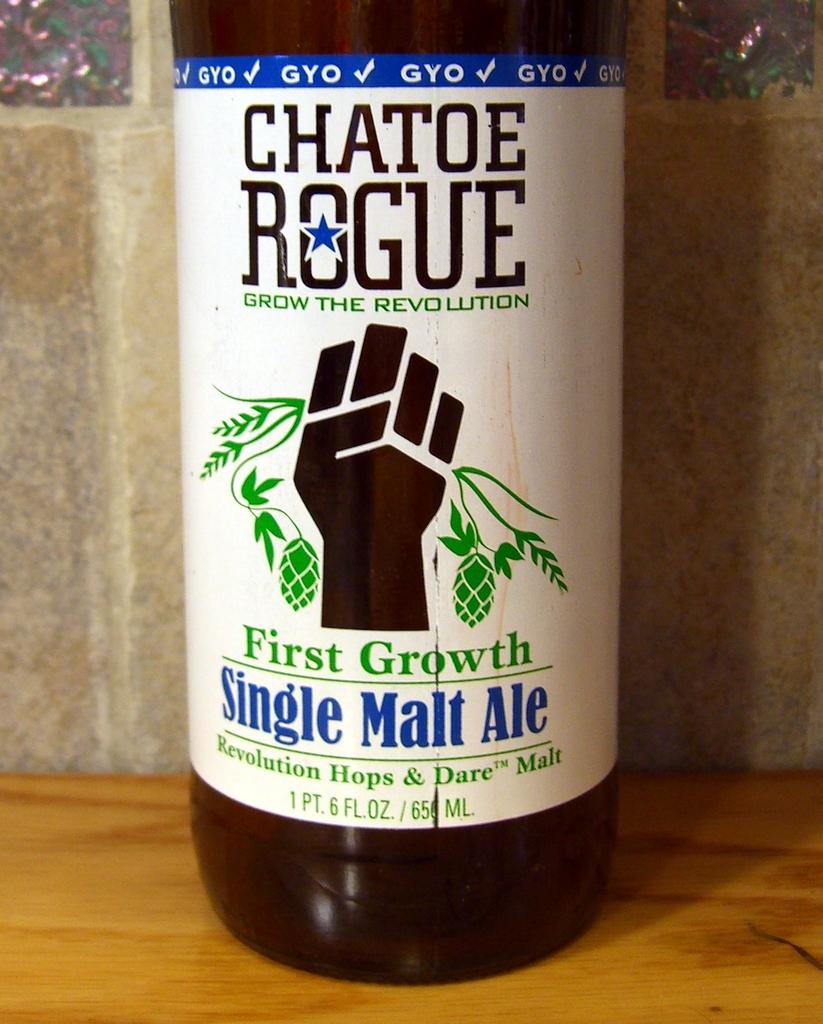How much liquid is contained in this drink?
Provide a succinct answer. 1 pt 6 fl oz. What kind of ale is this?
Offer a very short reply. Single malt. 